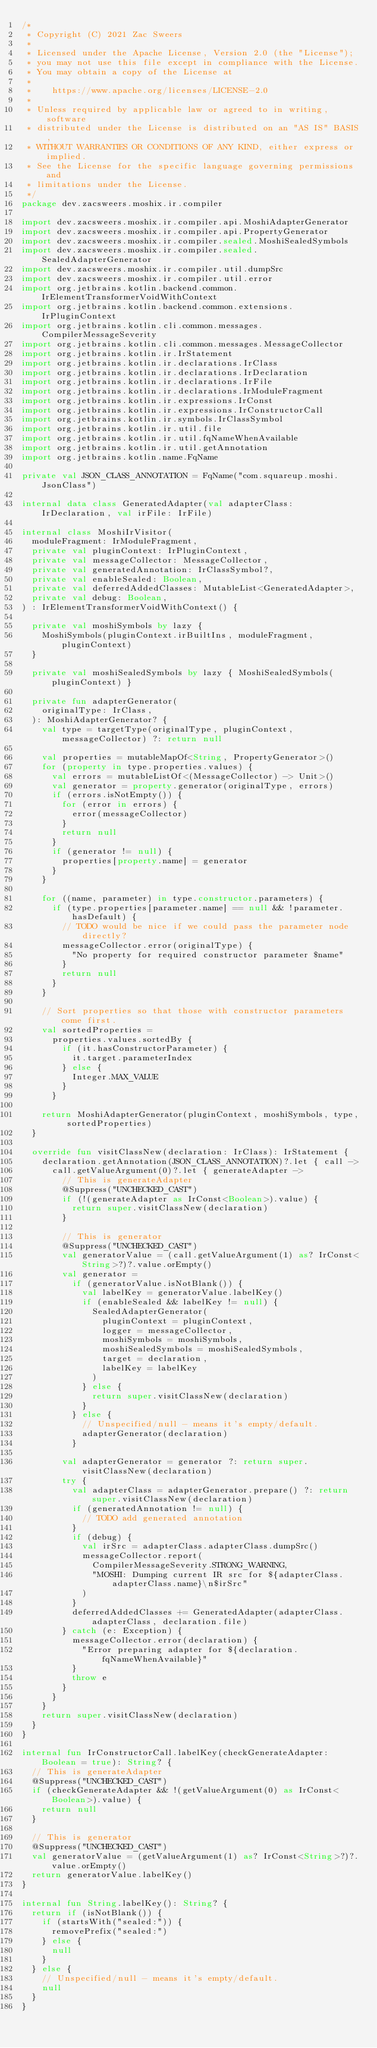Convert code to text. <code><loc_0><loc_0><loc_500><loc_500><_Kotlin_>/*
 * Copyright (C) 2021 Zac Sweers
 *
 * Licensed under the Apache License, Version 2.0 (the "License");
 * you may not use this file except in compliance with the License.
 * You may obtain a copy of the License at
 *
 *    https://www.apache.org/licenses/LICENSE-2.0
 *
 * Unless required by applicable law or agreed to in writing, software
 * distributed under the License is distributed on an "AS IS" BASIS,
 * WITHOUT WARRANTIES OR CONDITIONS OF ANY KIND, either express or implied.
 * See the License for the specific language governing permissions and
 * limitations under the License.
 */
package dev.zacsweers.moshix.ir.compiler

import dev.zacsweers.moshix.ir.compiler.api.MoshiAdapterGenerator
import dev.zacsweers.moshix.ir.compiler.api.PropertyGenerator
import dev.zacsweers.moshix.ir.compiler.sealed.MoshiSealedSymbols
import dev.zacsweers.moshix.ir.compiler.sealed.SealedAdapterGenerator
import dev.zacsweers.moshix.ir.compiler.util.dumpSrc
import dev.zacsweers.moshix.ir.compiler.util.error
import org.jetbrains.kotlin.backend.common.IrElementTransformerVoidWithContext
import org.jetbrains.kotlin.backend.common.extensions.IrPluginContext
import org.jetbrains.kotlin.cli.common.messages.CompilerMessageSeverity
import org.jetbrains.kotlin.cli.common.messages.MessageCollector
import org.jetbrains.kotlin.ir.IrStatement
import org.jetbrains.kotlin.ir.declarations.IrClass
import org.jetbrains.kotlin.ir.declarations.IrDeclaration
import org.jetbrains.kotlin.ir.declarations.IrFile
import org.jetbrains.kotlin.ir.declarations.IrModuleFragment
import org.jetbrains.kotlin.ir.expressions.IrConst
import org.jetbrains.kotlin.ir.expressions.IrConstructorCall
import org.jetbrains.kotlin.ir.symbols.IrClassSymbol
import org.jetbrains.kotlin.ir.util.file
import org.jetbrains.kotlin.ir.util.fqNameWhenAvailable
import org.jetbrains.kotlin.ir.util.getAnnotation
import org.jetbrains.kotlin.name.FqName

private val JSON_CLASS_ANNOTATION = FqName("com.squareup.moshi.JsonClass")

internal data class GeneratedAdapter(val adapterClass: IrDeclaration, val irFile: IrFile)

internal class MoshiIrVisitor(
  moduleFragment: IrModuleFragment,
  private val pluginContext: IrPluginContext,
  private val messageCollector: MessageCollector,
  private val generatedAnnotation: IrClassSymbol?,
  private val enableSealed: Boolean,
  private val deferredAddedClasses: MutableList<GeneratedAdapter>,
  private val debug: Boolean,
) : IrElementTransformerVoidWithContext() {

  private val moshiSymbols by lazy {
    MoshiSymbols(pluginContext.irBuiltIns, moduleFragment, pluginContext)
  }

  private val moshiSealedSymbols by lazy { MoshiSealedSymbols(pluginContext) }

  private fun adapterGenerator(
    originalType: IrClass,
  ): MoshiAdapterGenerator? {
    val type = targetType(originalType, pluginContext, messageCollector) ?: return null

    val properties = mutableMapOf<String, PropertyGenerator>()
    for (property in type.properties.values) {
      val errors = mutableListOf<(MessageCollector) -> Unit>()
      val generator = property.generator(originalType, errors)
      if (errors.isNotEmpty()) {
        for (error in errors) {
          error(messageCollector)
        }
        return null
      }
      if (generator != null) {
        properties[property.name] = generator
      }
    }

    for ((name, parameter) in type.constructor.parameters) {
      if (type.properties[parameter.name] == null && !parameter.hasDefault) {
        // TODO would be nice if we could pass the parameter node directly?
        messageCollector.error(originalType) {
          "No property for required constructor parameter $name"
        }
        return null
      }
    }

    // Sort properties so that those with constructor parameters come first.
    val sortedProperties =
      properties.values.sortedBy {
        if (it.hasConstructorParameter) {
          it.target.parameterIndex
        } else {
          Integer.MAX_VALUE
        }
      }

    return MoshiAdapterGenerator(pluginContext, moshiSymbols, type, sortedProperties)
  }

  override fun visitClassNew(declaration: IrClass): IrStatement {
    declaration.getAnnotation(JSON_CLASS_ANNOTATION)?.let { call ->
      call.getValueArgument(0)?.let { generateAdapter ->
        // This is generateAdapter
        @Suppress("UNCHECKED_CAST")
        if (!(generateAdapter as IrConst<Boolean>).value) {
          return super.visitClassNew(declaration)
        }

        // This is generator
        @Suppress("UNCHECKED_CAST")
        val generatorValue = (call.getValueArgument(1) as? IrConst<String>?)?.value.orEmpty()
        val generator =
          if (generatorValue.isNotBlank()) {
            val labelKey = generatorValue.labelKey()
            if (enableSealed && labelKey != null) {
              SealedAdapterGenerator(
                pluginContext = pluginContext,
                logger = messageCollector,
                moshiSymbols = moshiSymbols,
                moshiSealedSymbols = moshiSealedSymbols,
                target = declaration,
                labelKey = labelKey
              )
            } else {
              return super.visitClassNew(declaration)
            }
          } else {
            // Unspecified/null - means it's empty/default.
            adapterGenerator(declaration)
          }

        val adapterGenerator = generator ?: return super.visitClassNew(declaration)
        try {
          val adapterClass = adapterGenerator.prepare() ?: return super.visitClassNew(declaration)
          if (generatedAnnotation != null) {
            // TODO add generated annotation
          }
          if (debug) {
            val irSrc = adapterClass.adapterClass.dumpSrc()
            messageCollector.report(
              CompilerMessageSeverity.STRONG_WARNING,
              "MOSHI: Dumping current IR src for ${adapterClass.adapterClass.name}\n$irSrc"
            )
          }
          deferredAddedClasses += GeneratedAdapter(adapterClass.adapterClass, declaration.file)
        } catch (e: Exception) {
          messageCollector.error(declaration) {
            "Error preparing adapter for ${declaration.fqNameWhenAvailable}"
          }
          throw e
        }
      }
    }
    return super.visitClassNew(declaration)
  }
}

internal fun IrConstructorCall.labelKey(checkGenerateAdapter: Boolean = true): String? {
  // This is generateAdapter
  @Suppress("UNCHECKED_CAST")
  if (checkGenerateAdapter && !(getValueArgument(0) as IrConst<Boolean>).value) {
    return null
  }

  // This is generator
  @Suppress("UNCHECKED_CAST")
  val generatorValue = (getValueArgument(1) as? IrConst<String>?)?.value.orEmpty()
  return generatorValue.labelKey()
}

internal fun String.labelKey(): String? {
  return if (isNotBlank()) {
    if (startsWith("sealed:")) {
      removePrefix("sealed:")
    } else {
      null
    }
  } else {
    // Unspecified/null - means it's empty/default.
    null
  }
}
</code> 